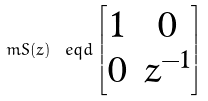Convert formula to latex. <formula><loc_0><loc_0><loc_500><loc_500>\ m S ( z ) \ e q d \begin{bmatrix} 1 & 0 \\ 0 & z ^ { - 1 } \end{bmatrix}</formula> 